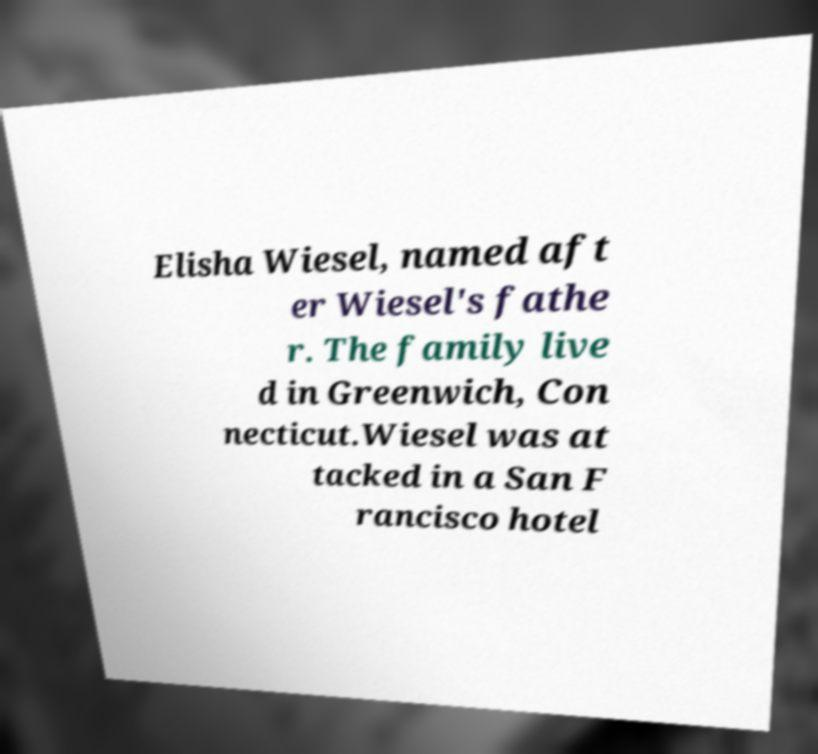Could you extract and type out the text from this image? Elisha Wiesel, named aft er Wiesel's fathe r. The family live d in Greenwich, Con necticut.Wiesel was at tacked in a San F rancisco hotel 